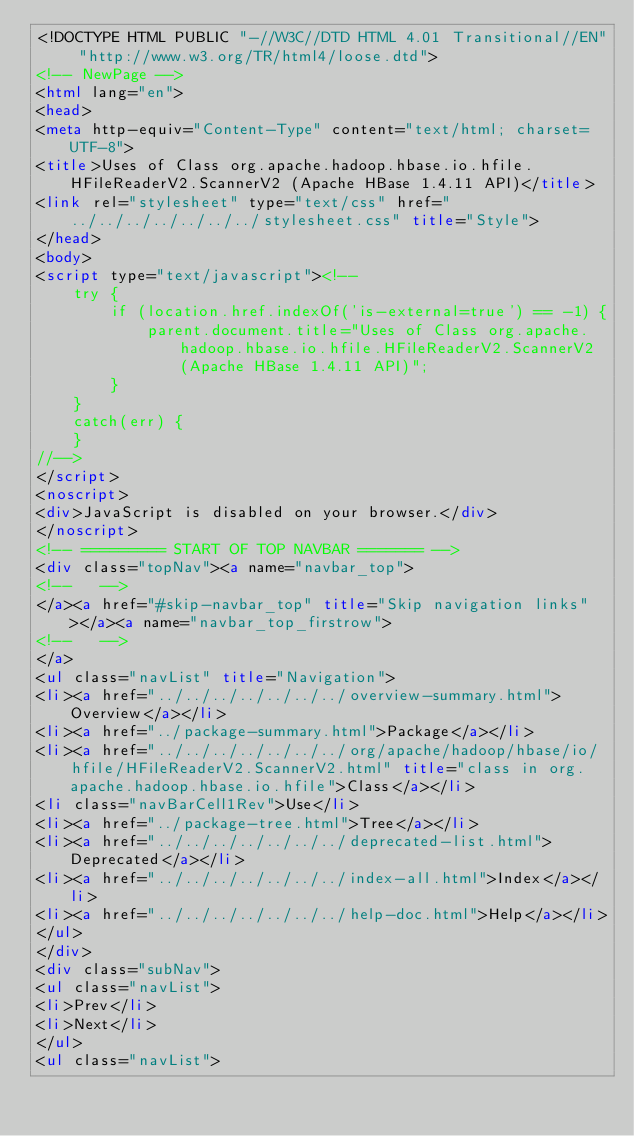Convert code to text. <code><loc_0><loc_0><loc_500><loc_500><_HTML_><!DOCTYPE HTML PUBLIC "-//W3C//DTD HTML 4.01 Transitional//EN" "http://www.w3.org/TR/html4/loose.dtd">
<!-- NewPage -->
<html lang="en">
<head>
<meta http-equiv="Content-Type" content="text/html; charset=UTF-8">
<title>Uses of Class org.apache.hadoop.hbase.io.hfile.HFileReaderV2.ScannerV2 (Apache HBase 1.4.11 API)</title>
<link rel="stylesheet" type="text/css" href="../../../../../../../stylesheet.css" title="Style">
</head>
<body>
<script type="text/javascript"><!--
    try {
        if (location.href.indexOf('is-external=true') == -1) {
            parent.document.title="Uses of Class org.apache.hadoop.hbase.io.hfile.HFileReaderV2.ScannerV2 (Apache HBase 1.4.11 API)";
        }
    }
    catch(err) {
    }
//-->
</script>
<noscript>
<div>JavaScript is disabled on your browser.</div>
</noscript>
<!-- ========= START OF TOP NAVBAR ======= -->
<div class="topNav"><a name="navbar_top">
<!--   -->
</a><a href="#skip-navbar_top" title="Skip navigation links"></a><a name="navbar_top_firstrow">
<!--   -->
</a>
<ul class="navList" title="Navigation">
<li><a href="../../../../../../../overview-summary.html">Overview</a></li>
<li><a href="../package-summary.html">Package</a></li>
<li><a href="../../../../../../../org/apache/hadoop/hbase/io/hfile/HFileReaderV2.ScannerV2.html" title="class in org.apache.hadoop.hbase.io.hfile">Class</a></li>
<li class="navBarCell1Rev">Use</li>
<li><a href="../package-tree.html">Tree</a></li>
<li><a href="../../../../../../../deprecated-list.html">Deprecated</a></li>
<li><a href="../../../../../../../index-all.html">Index</a></li>
<li><a href="../../../../../../../help-doc.html">Help</a></li>
</ul>
</div>
<div class="subNav">
<ul class="navList">
<li>Prev</li>
<li>Next</li>
</ul>
<ul class="navList"></code> 